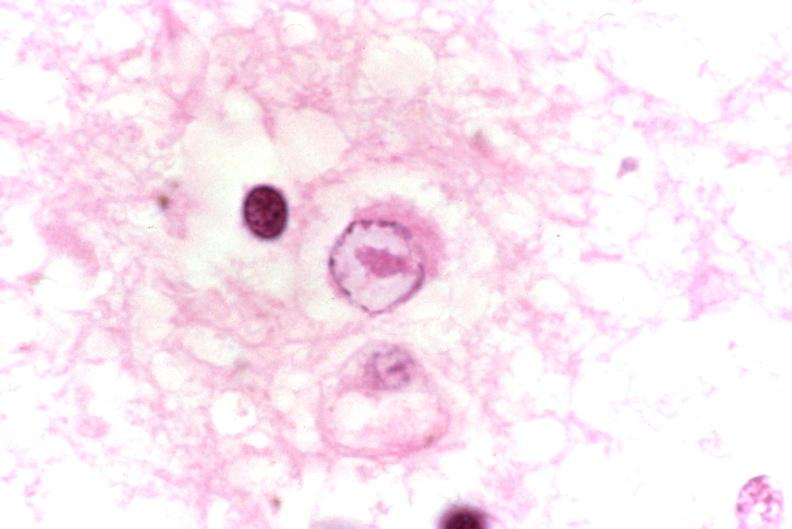s nervous present?
Answer the question using a single word or phrase. Yes 